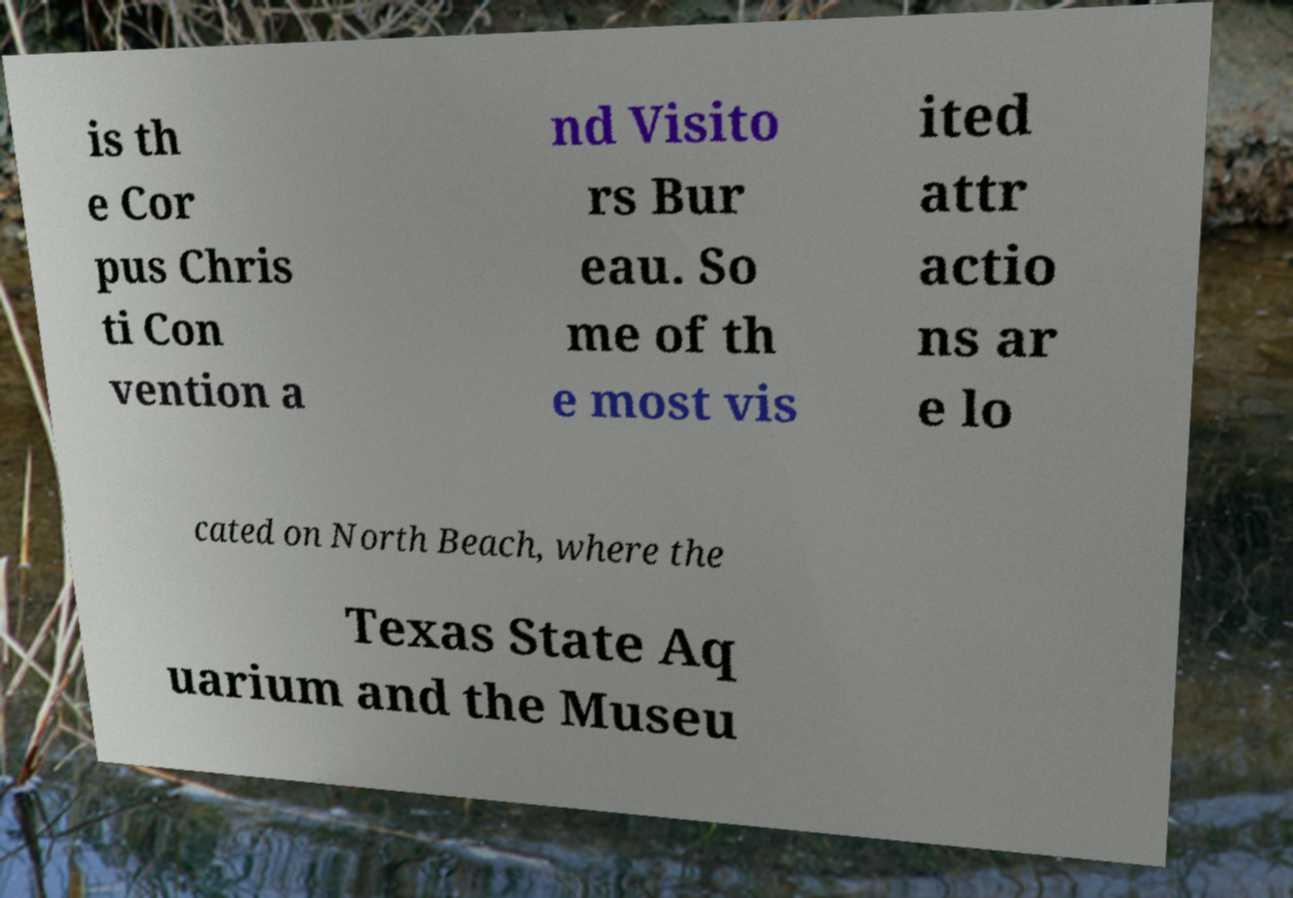What messages or text are displayed in this image? I need them in a readable, typed format. is th e Cor pus Chris ti Con vention a nd Visito rs Bur eau. So me of th e most vis ited attr actio ns ar e lo cated on North Beach, where the Texas State Aq uarium and the Museu 